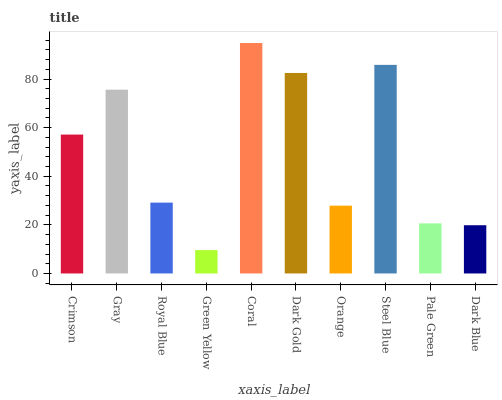Is Green Yellow the minimum?
Answer yes or no. Yes. Is Coral the maximum?
Answer yes or no. Yes. Is Gray the minimum?
Answer yes or no. No. Is Gray the maximum?
Answer yes or no. No. Is Gray greater than Crimson?
Answer yes or no. Yes. Is Crimson less than Gray?
Answer yes or no. Yes. Is Crimson greater than Gray?
Answer yes or no. No. Is Gray less than Crimson?
Answer yes or no. No. Is Crimson the high median?
Answer yes or no. Yes. Is Royal Blue the low median?
Answer yes or no. Yes. Is Gray the high median?
Answer yes or no. No. Is Green Yellow the low median?
Answer yes or no. No. 